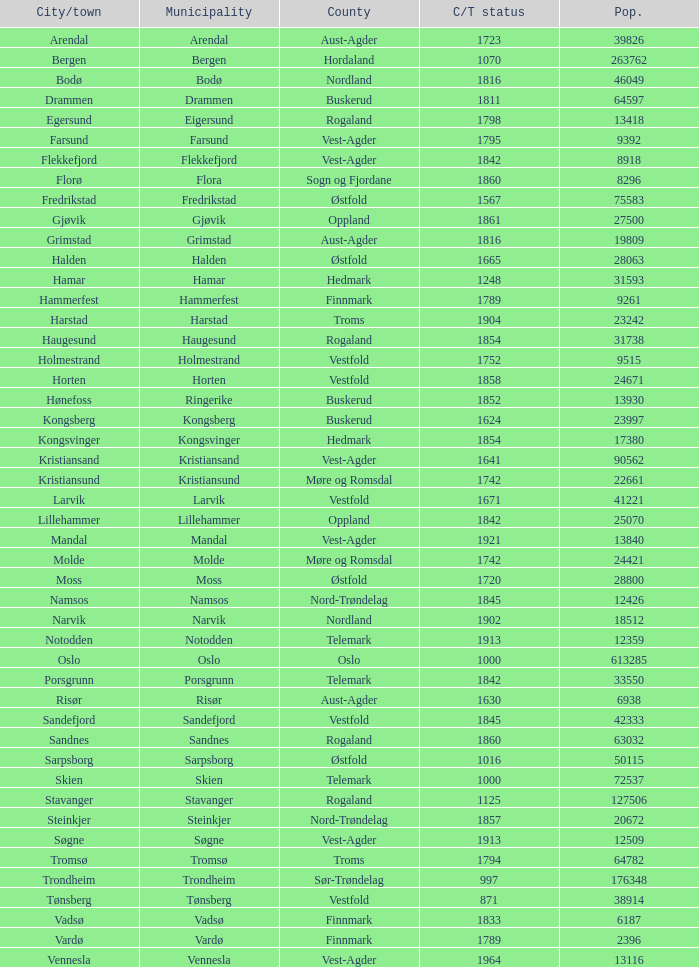Would you mind parsing the complete table? {'header': ['City/town', 'Municipality', 'County', 'C/T status', 'Pop.'], 'rows': [['Arendal', 'Arendal', 'Aust-Agder', '1723', '39826'], ['Bergen', 'Bergen', 'Hordaland', '1070', '263762'], ['Bodø', 'Bodø', 'Nordland', '1816', '46049'], ['Drammen', 'Drammen', 'Buskerud', '1811', '64597'], ['Egersund', 'Eigersund', 'Rogaland', '1798', '13418'], ['Farsund', 'Farsund', 'Vest-Agder', '1795', '9392'], ['Flekkefjord', 'Flekkefjord', 'Vest-Agder', '1842', '8918'], ['Florø', 'Flora', 'Sogn og Fjordane', '1860', '8296'], ['Fredrikstad', 'Fredrikstad', 'Østfold', '1567', '75583'], ['Gjøvik', 'Gjøvik', 'Oppland', '1861', '27500'], ['Grimstad', 'Grimstad', 'Aust-Agder', '1816', '19809'], ['Halden', 'Halden', 'Østfold', '1665', '28063'], ['Hamar', 'Hamar', 'Hedmark', '1248', '31593'], ['Hammerfest', 'Hammerfest', 'Finnmark', '1789', '9261'], ['Harstad', 'Harstad', 'Troms', '1904', '23242'], ['Haugesund', 'Haugesund', 'Rogaland', '1854', '31738'], ['Holmestrand', 'Holmestrand', 'Vestfold', '1752', '9515'], ['Horten', 'Horten', 'Vestfold', '1858', '24671'], ['Hønefoss', 'Ringerike', 'Buskerud', '1852', '13930'], ['Kongsberg', 'Kongsberg', 'Buskerud', '1624', '23997'], ['Kongsvinger', 'Kongsvinger', 'Hedmark', '1854', '17380'], ['Kristiansand', 'Kristiansand', 'Vest-Agder', '1641', '90562'], ['Kristiansund', 'Kristiansund', 'Møre og Romsdal', '1742', '22661'], ['Larvik', 'Larvik', 'Vestfold', '1671', '41221'], ['Lillehammer', 'Lillehammer', 'Oppland', '1842', '25070'], ['Mandal', 'Mandal', 'Vest-Agder', '1921', '13840'], ['Molde', 'Molde', 'Møre og Romsdal', '1742', '24421'], ['Moss', 'Moss', 'Østfold', '1720', '28800'], ['Namsos', 'Namsos', 'Nord-Trøndelag', '1845', '12426'], ['Narvik', 'Narvik', 'Nordland', '1902', '18512'], ['Notodden', 'Notodden', 'Telemark', '1913', '12359'], ['Oslo', 'Oslo', 'Oslo', '1000', '613285'], ['Porsgrunn', 'Porsgrunn', 'Telemark', '1842', '33550'], ['Risør', 'Risør', 'Aust-Agder', '1630', '6938'], ['Sandefjord', 'Sandefjord', 'Vestfold', '1845', '42333'], ['Sandnes', 'Sandnes', 'Rogaland', '1860', '63032'], ['Sarpsborg', 'Sarpsborg', 'Østfold', '1016', '50115'], ['Skien', 'Skien', 'Telemark', '1000', '72537'], ['Stavanger', 'Stavanger', 'Rogaland', '1125', '127506'], ['Steinkjer', 'Steinkjer', 'Nord-Trøndelag', '1857', '20672'], ['Søgne', 'Søgne', 'Vest-Agder', '1913', '12509'], ['Tromsø', 'Tromsø', 'Troms', '1794', '64782'], ['Trondheim', 'Trondheim', 'Sør-Trøndelag', '997', '176348'], ['Tønsberg', 'Tønsberg', 'Vestfold', '871', '38914'], ['Vadsø', 'Vadsø', 'Finnmark', '1833', '6187'], ['Vardø', 'Vardø', 'Finnmark', '1789', '2396'], ['Vennesla', 'Vennesla', 'Vest-Agder', '1964', '13116']]} What is the total population in the city/town of Arendal? 1.0. 